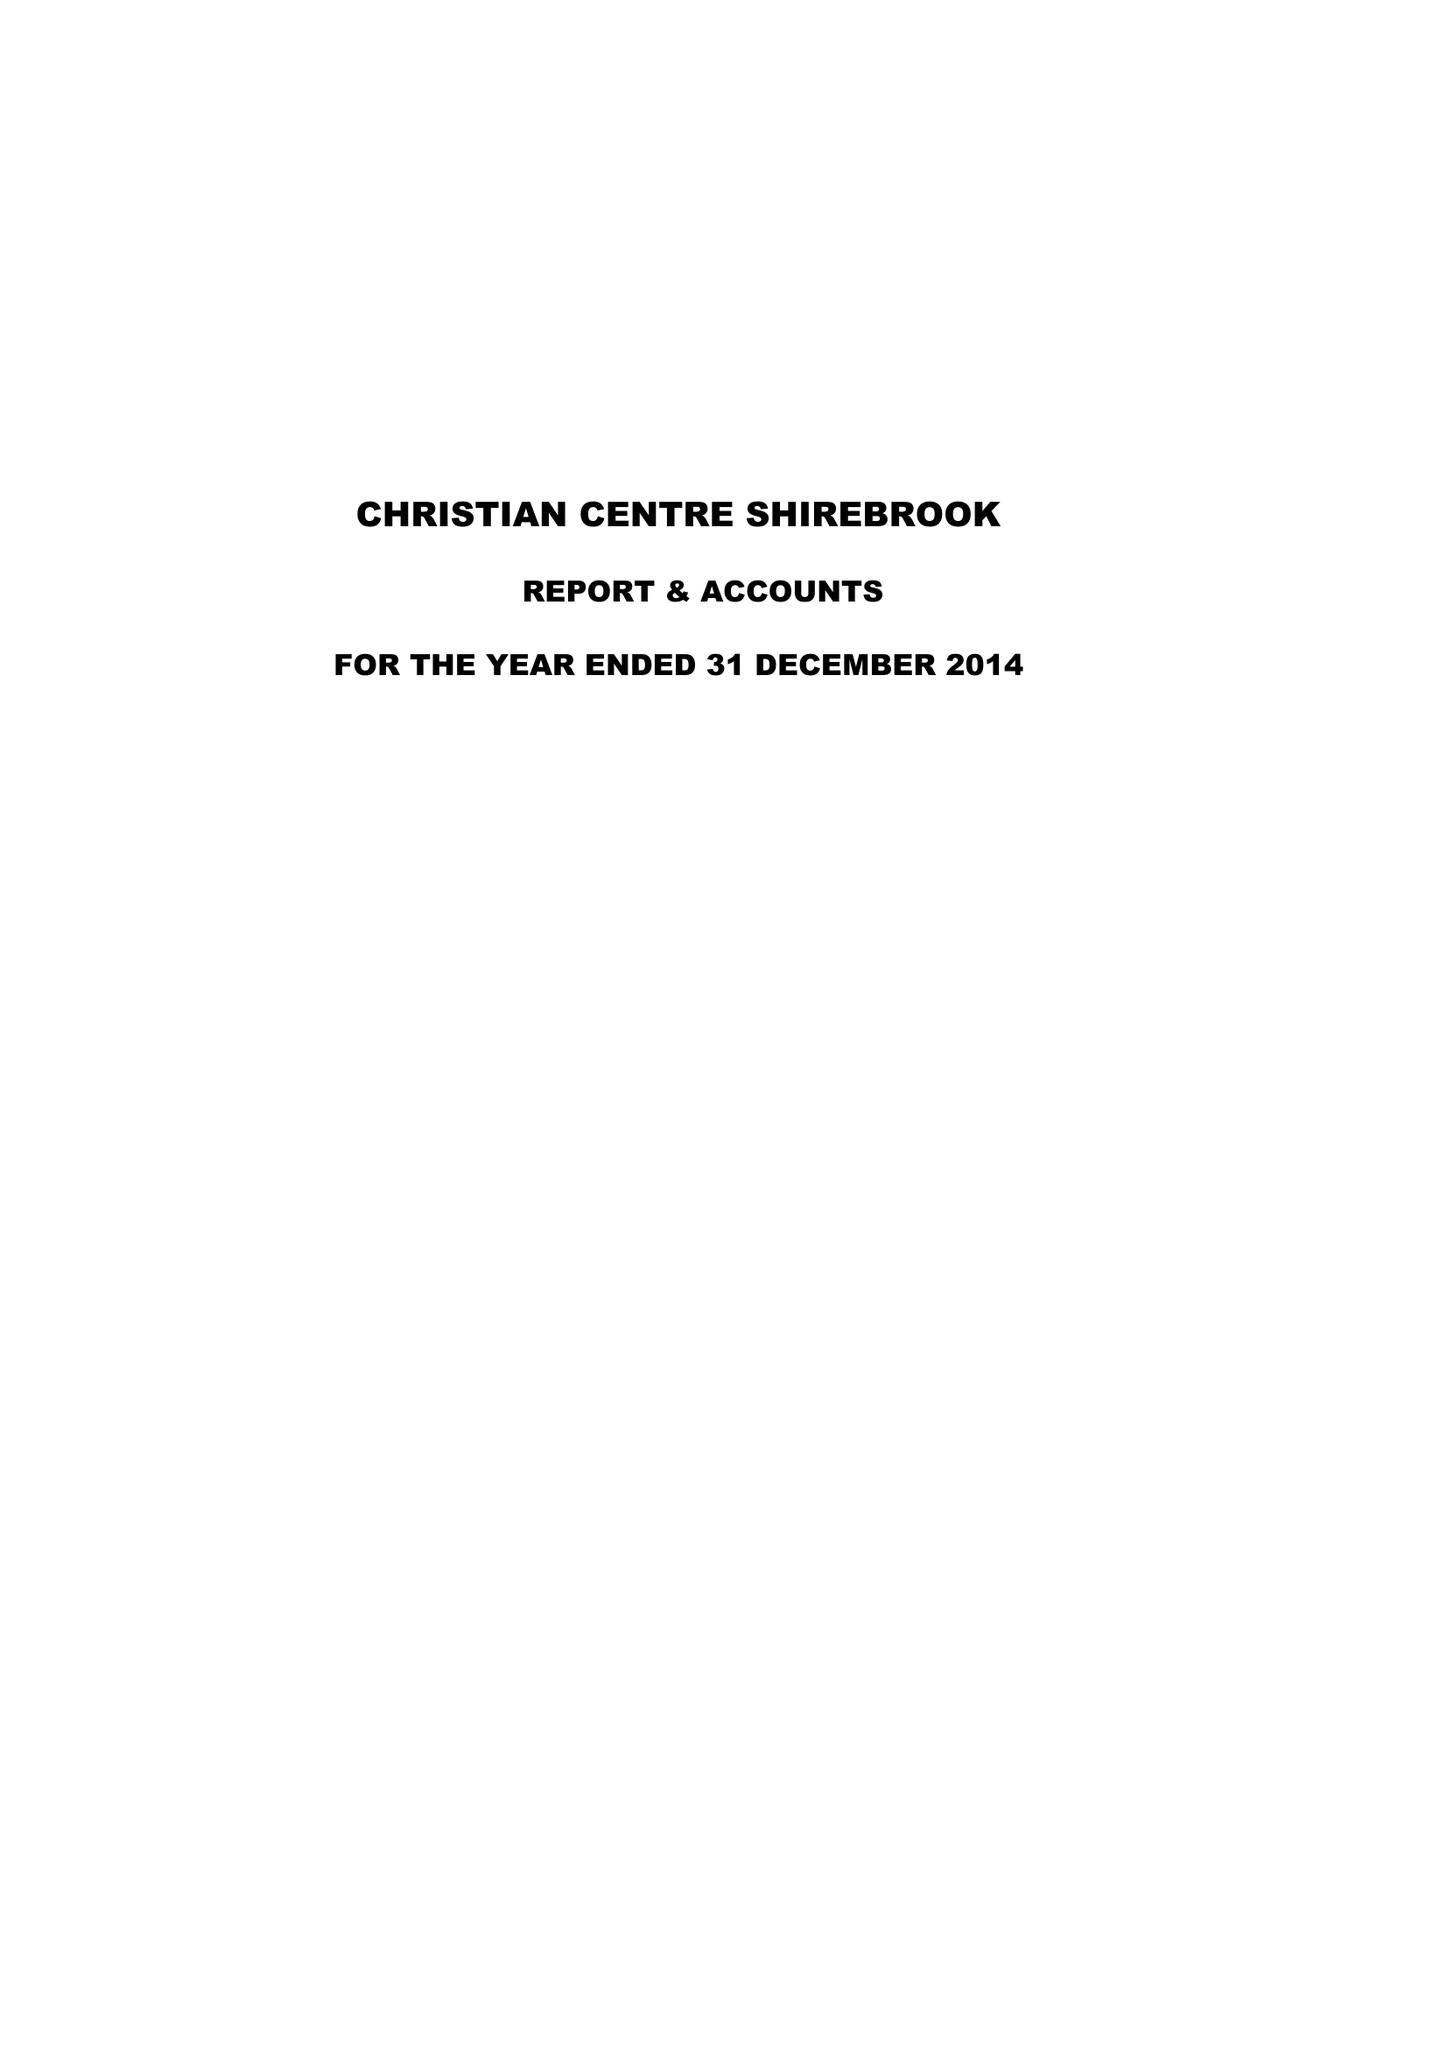What is the value for the spending_annually_in_british_pounds?
Answer the question using a single word or phrase. 47307.00 